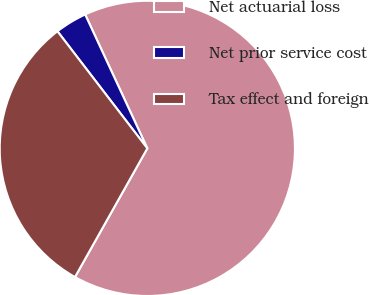<chart> <loc_0><loc_0><loc_500><loc_500><pie_chart><fcel>Net actuarial loss<fcel>Net prior service cost<fcel>Tax effect and foreign<nl><fcel>65.07%<fcel>3.5%<fcel>31.43%<nl></chart> 